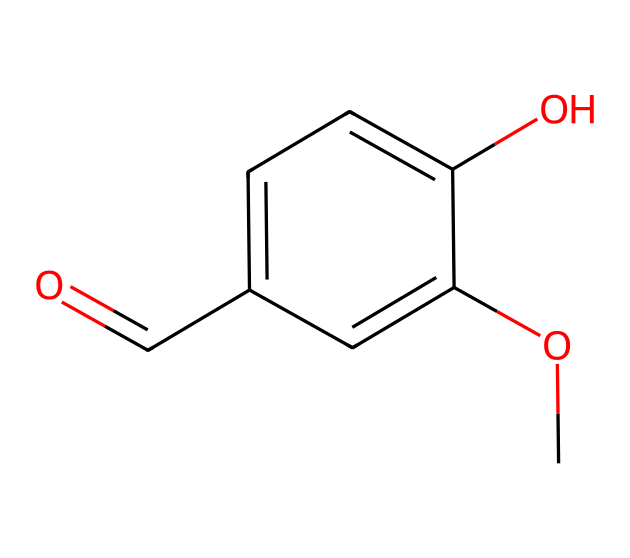What is the common name of this chemical? The SMILES representation shows a structure commonly known for its use in flavoring, particularly in vanilla products. This structure corresponds to vanillin.
Answer: vanillin How many carbon atoms are present in this molecule? By analyzing the SMILES notation, we can count the number of carbon atoms explicitly represented in the structure. There are eight carbon atoms in total.
Answer: 8 What functional group is indicated by the "O=" in the SMILES? The "O=" notation indicates the presence of a carbonyl group, which is a defining feature of aldehydes. In this case, it places the molecule in the aromatic aldehyde category.
Answer: carbonyl Which substituent is responsible for the sweetness of this flavoring agent? The presence of the methoxy group (OC) in the structure contributes significantly to the flavor profile of vanillin, enhancing its sweetness when used in foods.
Answer: methoxy group How many hydroxyl (OH) groups are in this molecule? The structure indicates one hydroxyl group (-OH) attached to the aromatic ring, which plays a role in the solubility and interaction of vanillin in baking and cooking.
Answer: 1 Is this molecule hydrophilic or hydrophobic? Based on the presence of hydroxyl groups and methoxy groups in the structure, the molecule is more hydrophilic as these functional groups increase its ability to interact with water.
Answer: hydrophilic What is the role of vanillin in food? Vanillin is primarily used as a flavoring agent in various food products, providing a sweet, aromatic flavor that enhances the overall taste of baked goods and desserts.
Answer: flavoring agent 